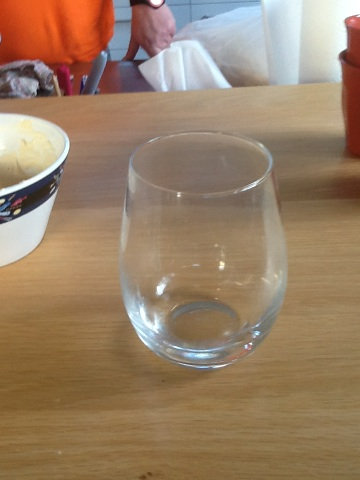Please describe any distinctive features of this wine glass. This stemless wine glass has a broad, rounded base that narrows slightly towards the rim. It's made of clear glass, allowing the color of the wine to be prominently displayed. 